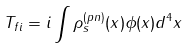Convert formula to latex. <formula><loc_0><loc_0><loc_500><loc_500>T _ { f i } = i \int \rho _ { s } ^ { ( p n ) } ( x ) \phi ( x ) d ^ { 4 } x</formula> 